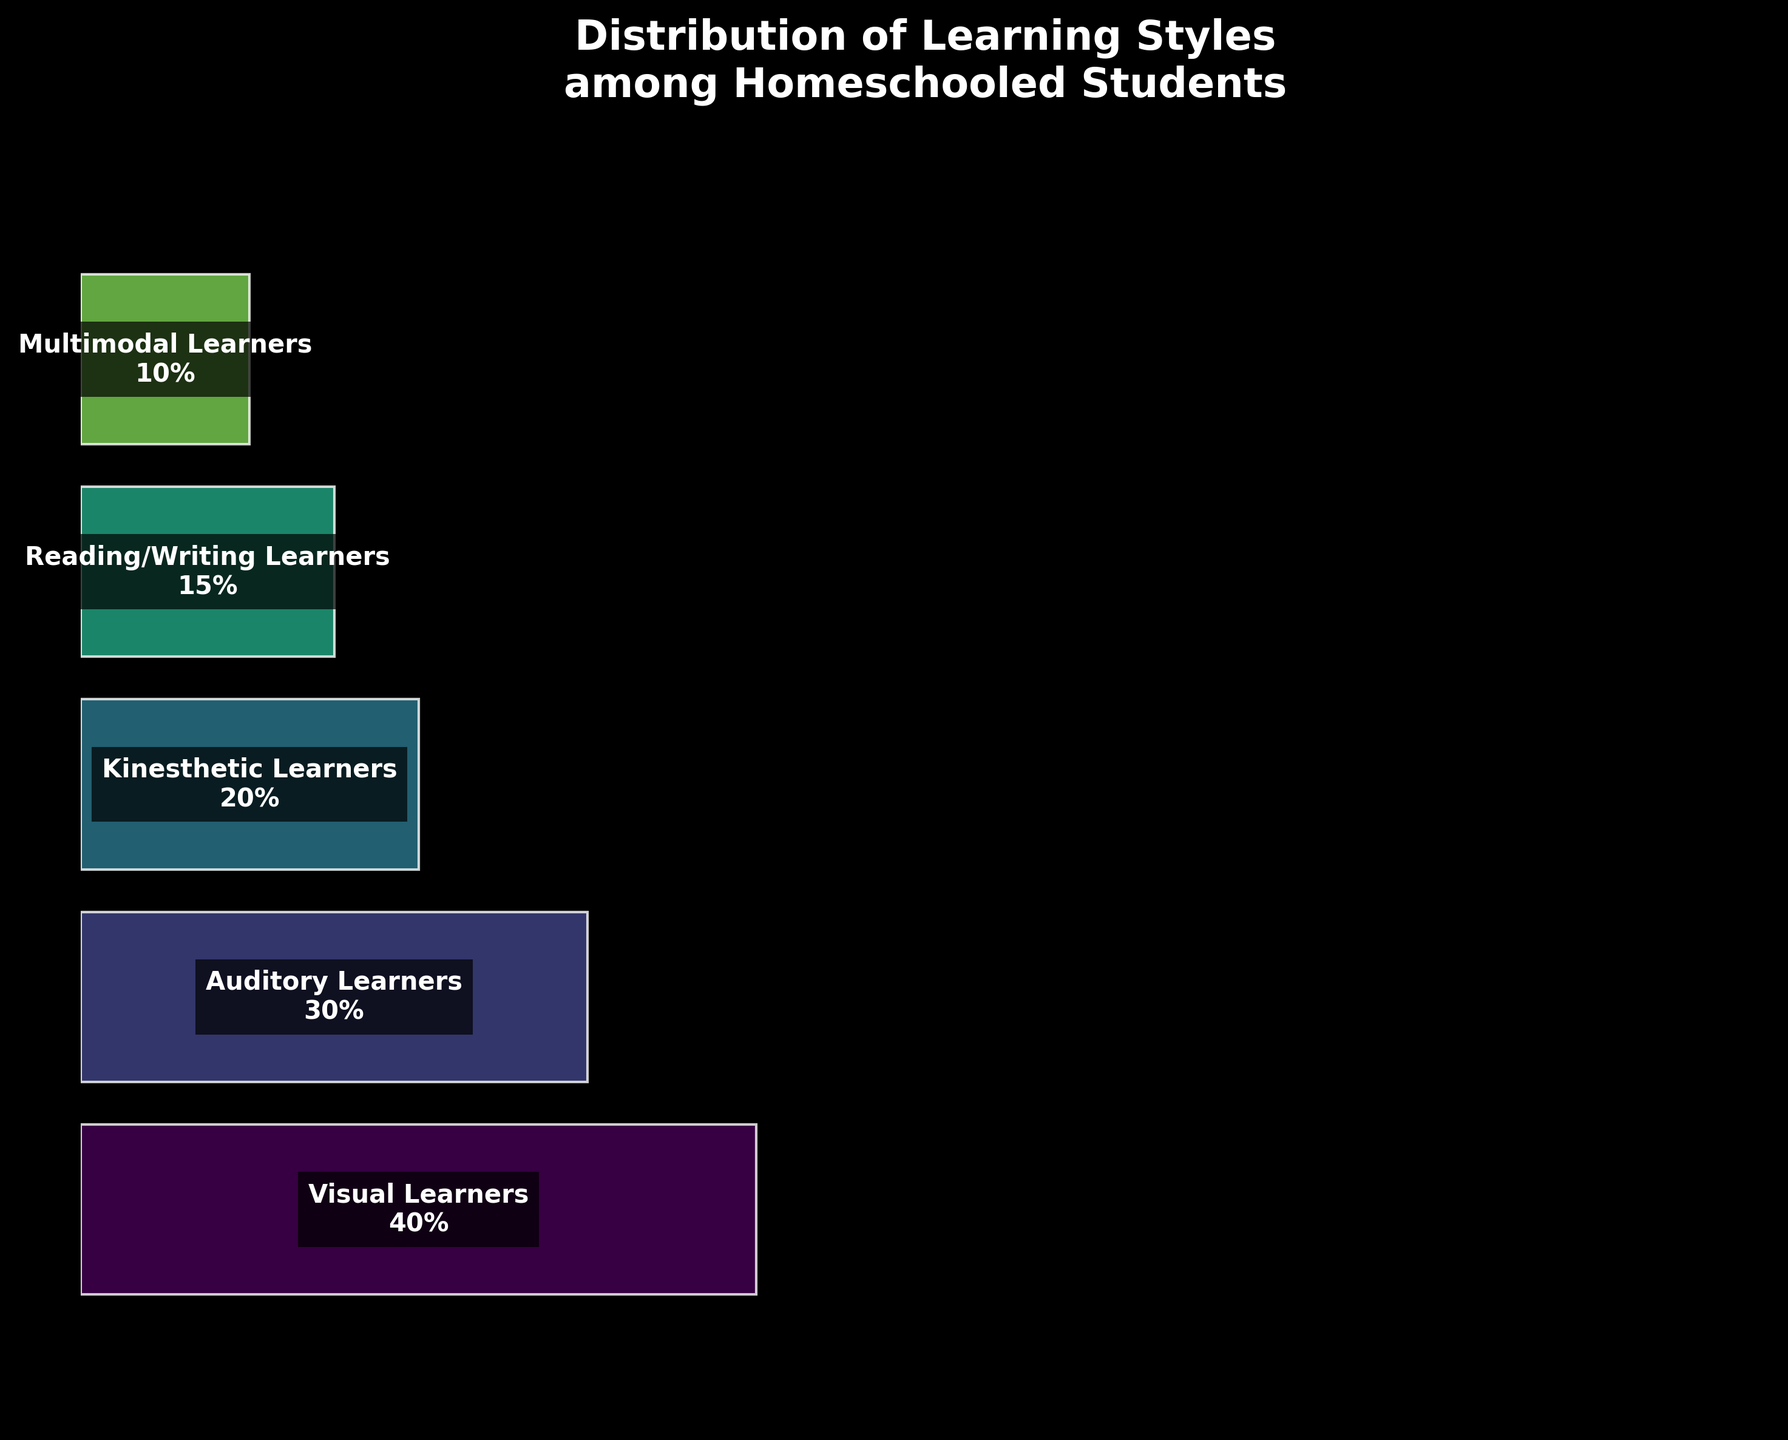What is the title of the figure? The title is printed at the top of the figure and reads: "Distribution of Learning Styles among Homeschooled Students".
Answer: Distribution of Learning Styles among Homeschooled Students Which learning style has the highest percentage? The visual style has the largest width in the funnel, indicating the highest percentage. The label inside this segment confirms the value is 40%.
Answer: Visual Learners How many learning styles are depicted in the chart? The chart displays separate segments for each learning style. By counting these segments, we find that there are five learning styles shown.
Answer: 5 What is the percentage difference between Visual Learners and Kinesthetic Learners? The Visual Learners have a percentage of 40% and Kinesthetic Learners have 20%. The difference is calculated as 40% - 20% = 20%.
Answer: 20% Which learning style has a lower percentage, Auditory Learners or Reading/Writing Learners? Auditory Learners have a percentage of 30%, and Reading/Writing Learners have 15%. Since 15% is lower than 30%, Reading/Writing Learners have a lower percentage.
Answer: Reading/Writing Learners What is the combined percentage of Auditory Learners and Reading/Writing Learners? The values for Auditory Learners (30%) and Reading/Writing Learners (15%) are added together to get 30% + 15% = 45%.
Answer: 45% Is the percentage of Multimodal Learners greater than or equal to 10%? The percentage for Multimodal Learners in the figure is explicitly shown as 10%. Therefore, it is equal to 10%.
Answer: Equal to 10% By how much is the percentage of Kinesthetic Learners greater than Reading/Writing Learners? The percentage for Kinesthetic Learners is 20%, and for Reading/Writing Learners it is 15%. The difference is calculated as 20% - 15% = 5%.
Answer: 5% Which segment in the chart has the second-largest percentage? The Visual Learners segment is the largest (40%), followed by the Auditory Learners segment, which has the second-largest percentage at 30%.
Answer: Auditory Learners What is the average percentage of all learning styles depicted? Summing up the percentages for Visual (40%), Auditory (30%), Kinesthetic (20%), Reading/Writing (15%), and Multimodal (10%) gives 115%. Dividing this total by the 5 learning styles results in an average of 115% / 5 = 23%.
Answer: 23% 